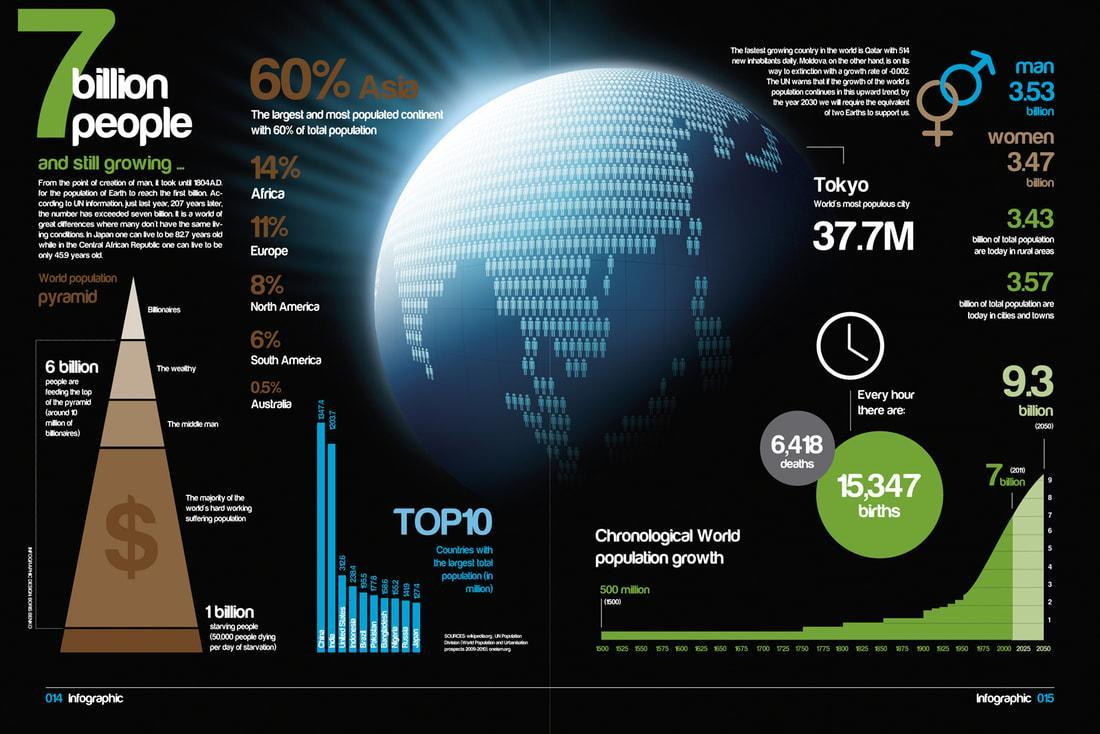What is the percentage of the population in Africa and Europe, taken together?
Answer the question with a short phrase. 25% What is the percentage of the population in North America and South America, taken together? 14% What is the population in rural, city, and town areas? 7 billion What is the difference between the number of births and deaths in every hour? 8929 